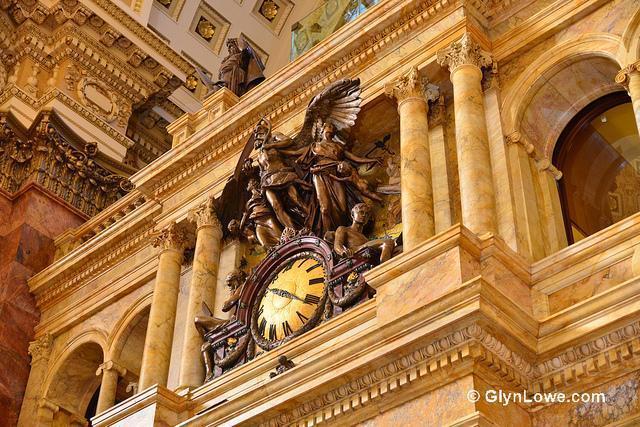How many clocks are there?
Give a very brief answer. 1. 